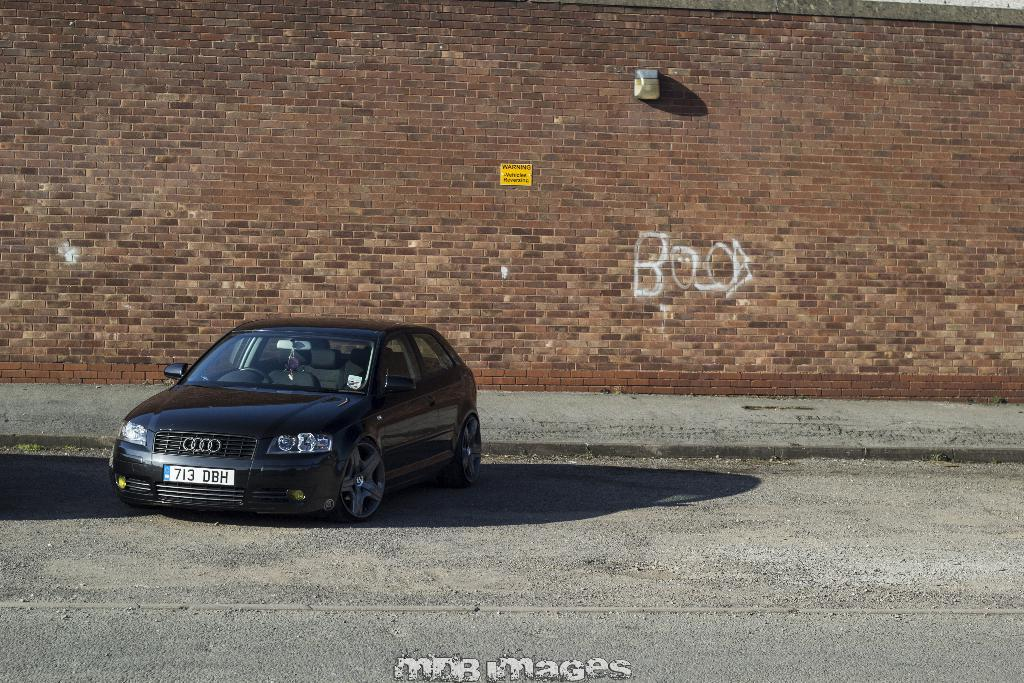What is the main object on the ground in the image? There is a car on the ground in the image. What can be seen in the background of the image? There is a wall in the background of the image. What additional information is provided at the bottom of the image? There is edited text at the bottom of the image. What type of jelly is being used to decorate the car in the image? There is no jelly present in the image, and the car is not being decorated with any jelly. 